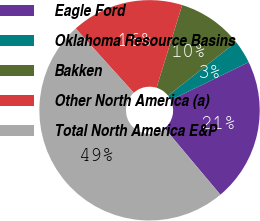Convert chart to OTSL. <chart><loc_0><loc_0><loc_500><loc_500><pie_chart><fcel>Eagle Ford<fcel>Oklahoma Resource Basins<fcel>Bakken<fcel>Other North America (a)<fcel>Total North America E&P<nl><fcel>21.07%<fcel>3.44%<fcel>9.59%<fcel>16.47%<fcel>49.42%<nl></chart> 